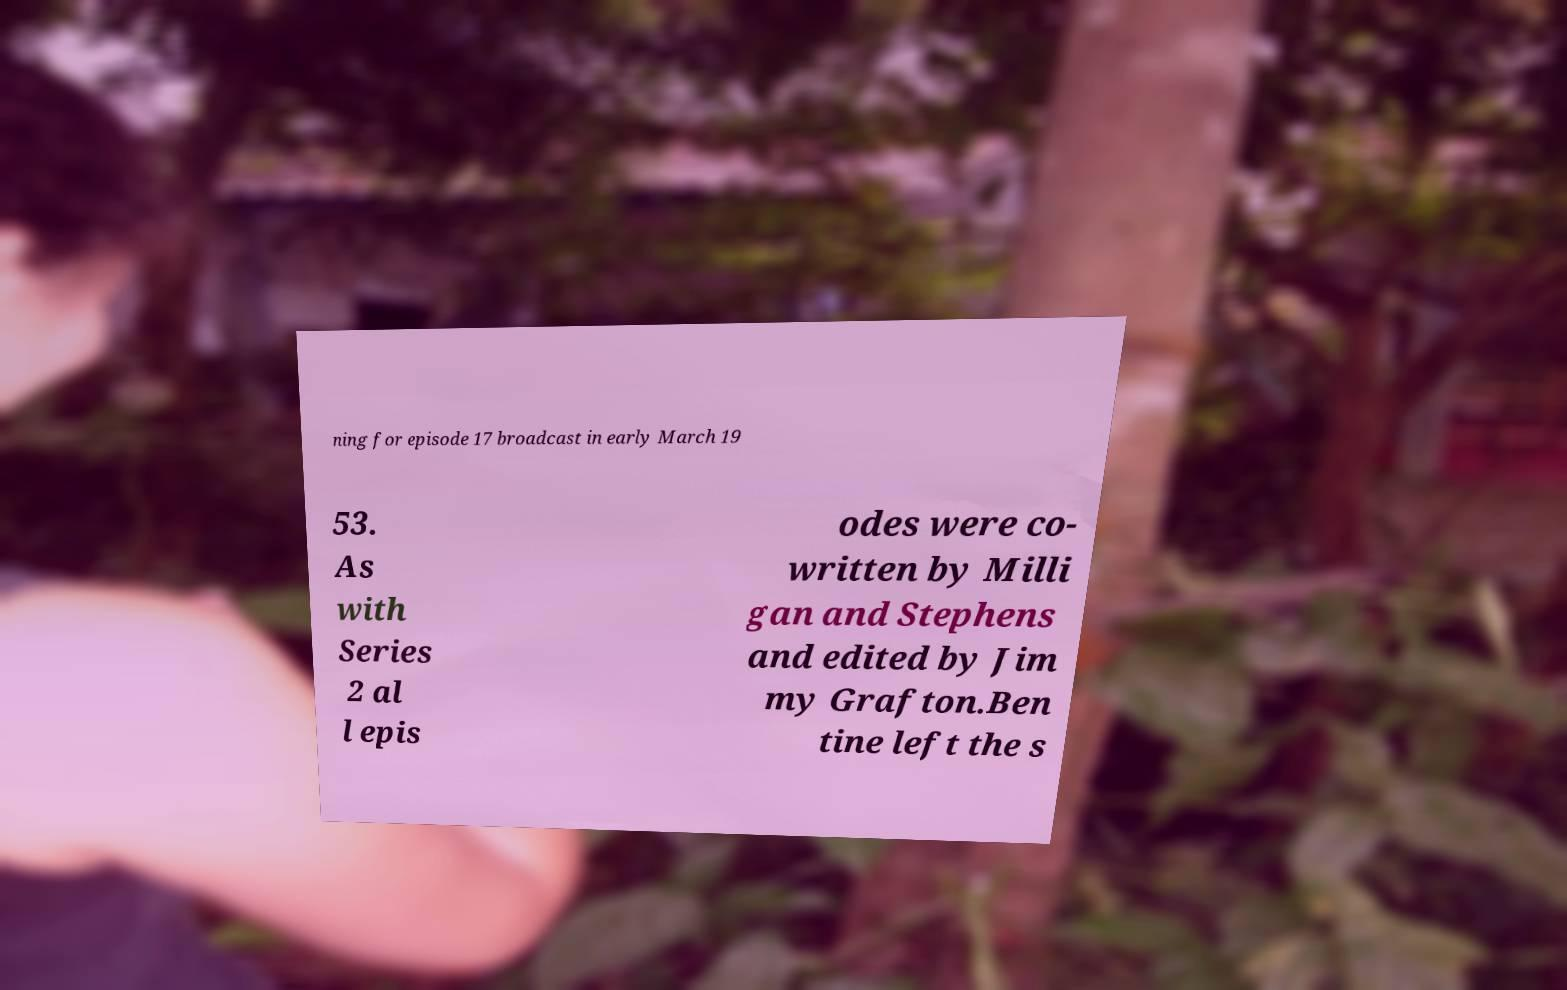Can you read and provide the text displayed in the image?This photo seems to have some interesting text. Can you extract and type it out for me? ning for episode 17 broadcast in early March 19 53. As with Series 2 al l epis odes were co- written by Milli gan and Stephens and edited by Jim my Grafton.Ben tine left the s 